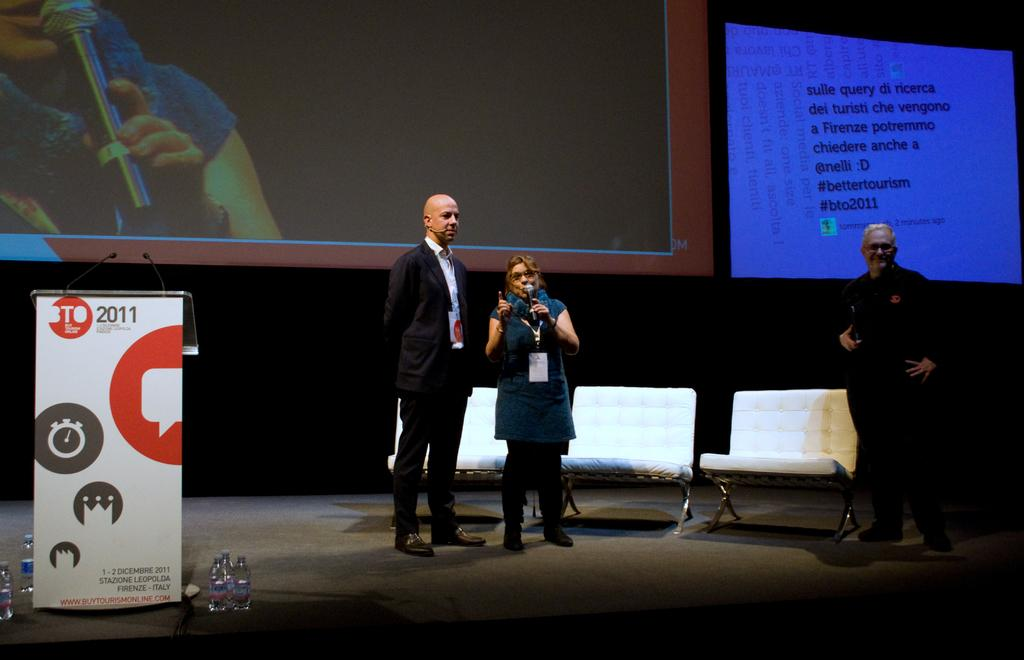How many people are in the image? There are three people in the image. Can you describe the gender of the people in the image? Two of the people are men, and one is a woman. Where are the people standing in the image? The people are standing on a dais. What is the woman doing in the image? The woman is speaking using a microphone. What object is present for the people to use for their speeches? There is a podium in the image. What items are present for hydration in the image? There are water bottles in the image. What is the purpose of the projector screen in the image? The projector screen is likely used for displaying visual aids during the presentation. Can you see a maid cleaning the room in the image? There is no maid present in the image. Is there a baseball game happening in the background of the image? There is no baseball game or any reference to sports in the image. 